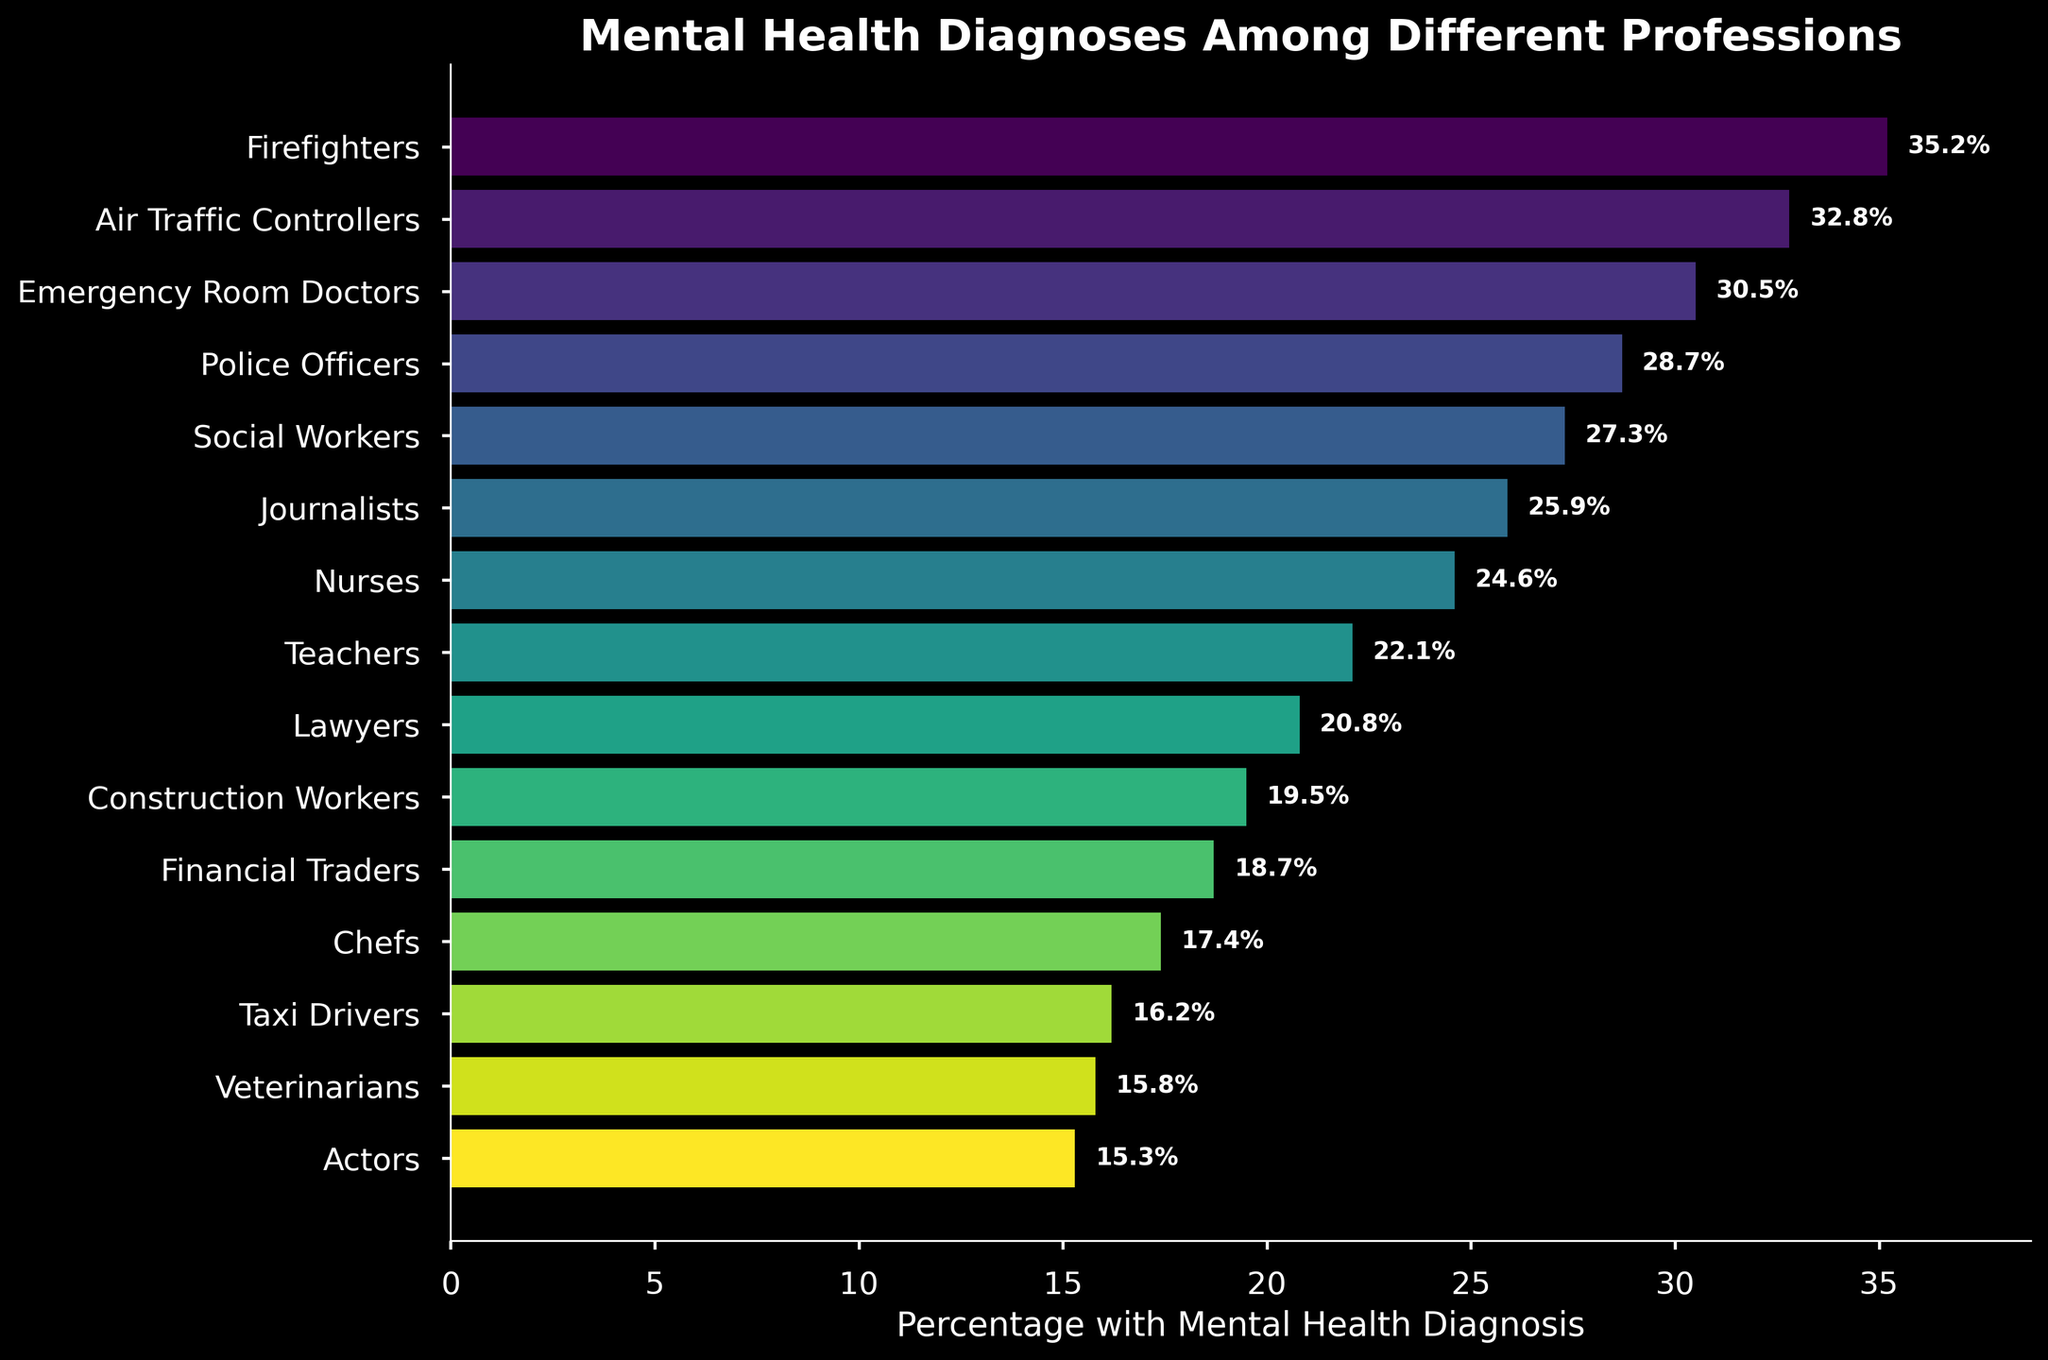Which profession has the highest percentage of mental health diagnoses? The bar chart shows the percentage of mental health diagnoses for each profession. By comparing the lengths of the bars, we can see that Firefighters have the highest percentage.
Answer: Firefighters What percentage of Air Traffic Controllers have mental health diagnoses? The chart lists the percentage of mental health diagnoses next to each profession. By looking at Air Traffic Controllers, we see they have 32.8%.
Answer: 32.8% Which profession has a lower percentage of mental health diagnoses: Chefs or Taxi Drivers? The bar corresponding to Chefs is labeled with 17.4%, and the one for Taxi Drivers is labeled with 16.2%. Comparing these, Taxi Drivers have a lower percentage.
Answer: Taxi Drivers What is the average percentage of mental health diagnoses among Firefighters, Police Officers, and Teachers? To find the average, we add the percentages of these professions and divide by 3. (35.2 + 28.7 + 22.1) / 3 = 86 / 3 = 28.67
Answer: 28.67 How much higher is the percentage of mental health diagnoses for Journalists compared to Chefs? The percentage for Journalists is 25.9% and for Chefs is 17.4%. The difference is 25.9 - 17.4 = 8.5.
Answer: 8.5 Which profession has the third-highest percentage of mental health diagnoses? By arranging the bars in descending order of length (excluding the labels and focusing on the heights), we can see the third highest is Emergency Room Doctors with 30.5%.
Answer: Emergency Room Doctors How does the mental health diagnosis percentage of Social Workers compare to Lawyers? The bar for Social Workers shows 27.3% and for Lawyers shows 20.8%. Social Workers have a higher percentage than Lawyers.
Answer: Social Workers What is the combined percentage of mental health diagnoses for Veterinarians and Actors? Adding the percentages for Veterinarians and Actors, we get 15.8 + 15.3 = 31.1%.
Answer: 31.1 What is the difference in percentage of mental health diagnoses between the highest and lowest professions? The highest percentage is for Firefighters at 35.2% and the lowest is for Actors at 15.3%. The difference is 35.2 - 15.3 = 19.9%.
Answer: 19.9 How does the percentage of mental health diagnoses for Nurses compare to Construction Workers? The bar for Nurses indicates 24.6% and for Construction Workers it indicates 19.5%. Nurses have a higher percentage than Construction Workers.
Answer: Nurses 